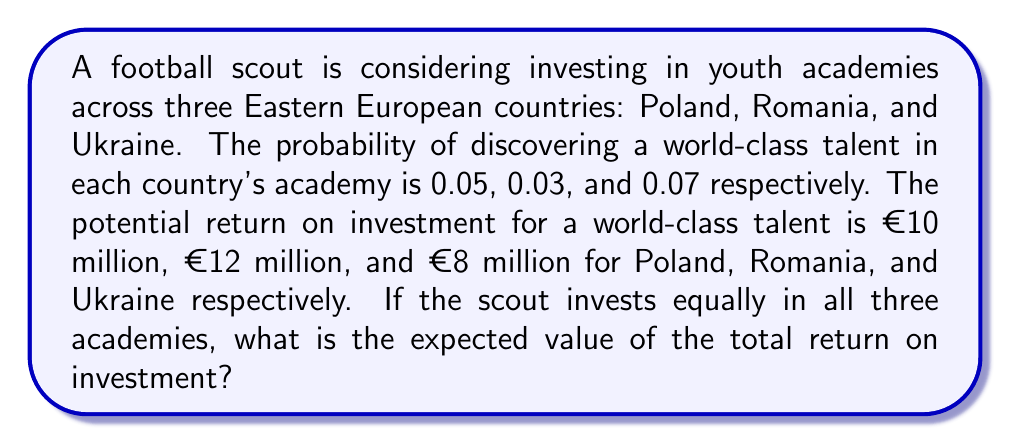Can you solve this math problem? To solve this problem, we need to calculate the expected value for each country and then sum them up. The expected value is calculated by multiplying the probability of success by the potential return.

1. For Poland:
   Probability = 0.05
   Potential return = €10 million
   Expected value = $0.05 \times €10$ million = €0.5 million

2. For Romania:
   Probability = 0.03
   Potential return = €12 million
   Expected value = $0.03 \times €12$ million = €0.36 million

3. For Ukraine:
   Probability = 0.07
   Potential return = €8 million
   Expected value = $0.07 \times €8$ million = €0.56 million

Now, we sum up the expected values for all three countries:

$$\text{Total Expected Value} = €0.5\text{ million} + €0.36\text{ million} + €0.56\text{ million} = €1.42\text{ million}$$

Therefore, the expected value of the total return on investment is €1.42 million.
Answer: €1.42 million 